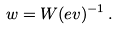Convert formula to latex. <formula><loc_0><loc_0><loc_500><loc_500>w = W ( e v ) ^ { - 1 } \, .</formula> 